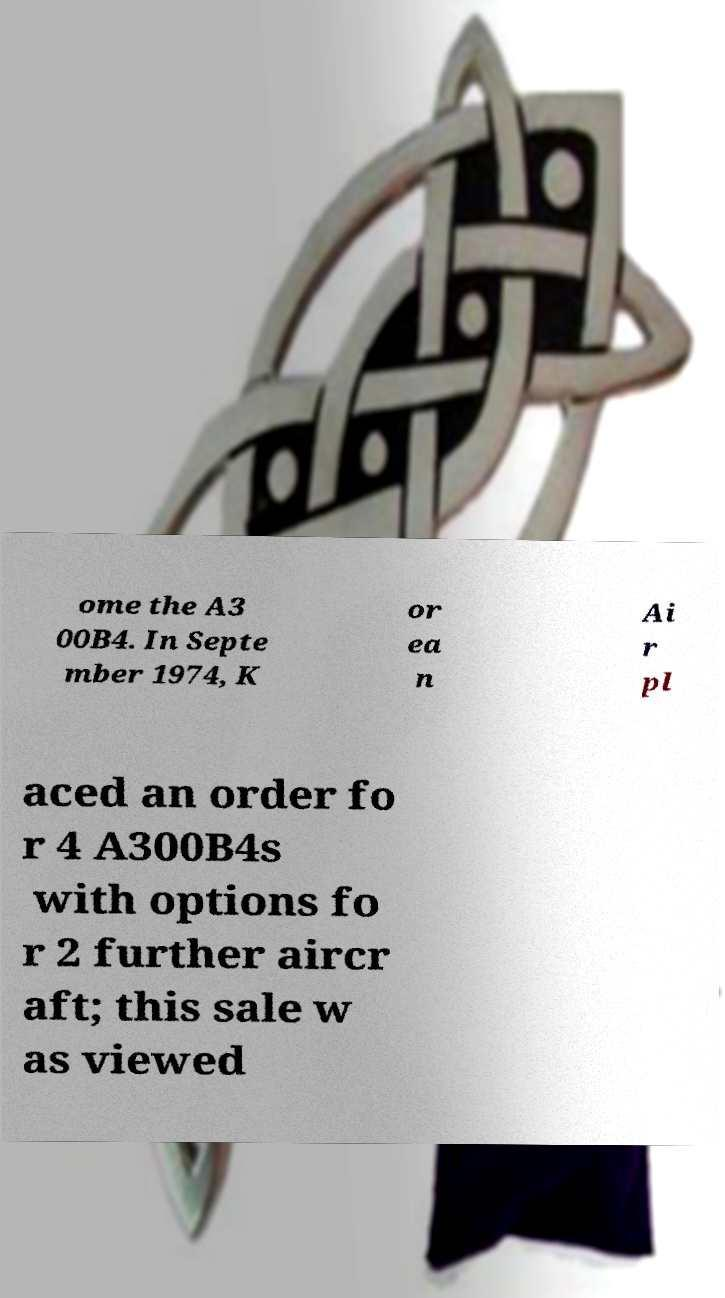Could you assist in decoding the text presented in this image and type it out clearly? ome the A3 00B4. In Septe mber 1974, K or ea n Ai r pl aced an order fo r 4 A300B4s with options fo r 2 further aircr aft; this sale w as viewed 